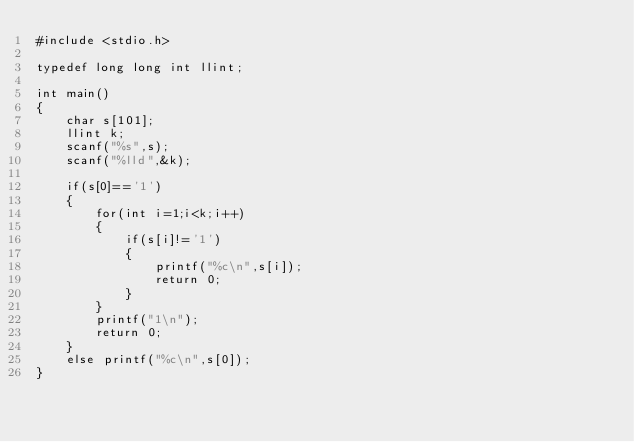<code> <loc_0><loc_0><loc_500><loc_500><_C++_>#include <stdio.h>

typedef long long int llint;

int main()
{
    char s[101];
    llint k;
    scanf("%s",s);
    scanf("%lld",&k);

    if(s[0]=='1')
    {
        for(int i=1;i<k;i++)
        {
            if(s[i]!='1')
            {
                printf("%c\n",s[i]);
                return 0;
            }
        }
        printf("1\n");
        return 0;
    }
    else printf("%c\n",s[0]);
}</code> 